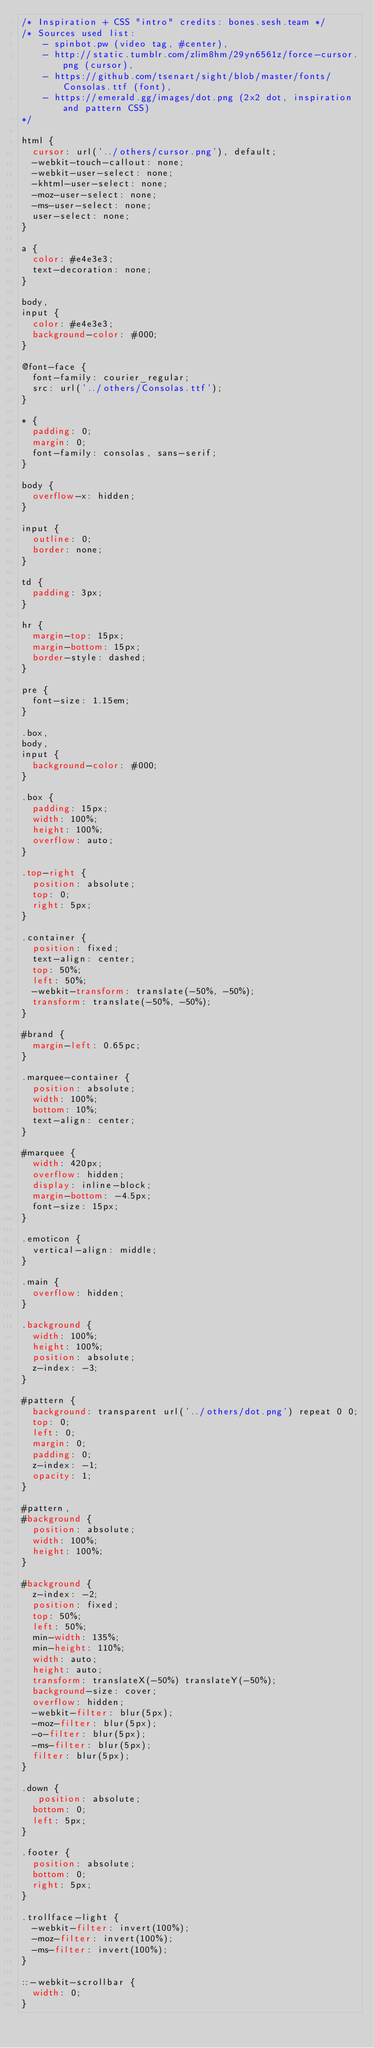Convert code to text. <code><loc_0><loc_0><loc_500><loc_500><_CSS_>/* Inspiration + CSS "intro" credits: bones.sesh.team */
/* Sources used list:
    - spinbot.pw (video tag, #center),
    - http://static.tumblr.com/zlim8hm/29yn6561z/force-cursor.png (cursor),
    - https://github.com/tsenart/sight/blob/master/fonts/Consolas.ttf (font),
    - https://emerald.gg/images/dot.png (2x2 dot, inspiration and pattern CSS)
*/

html {
  cursor: url('../others/cursor.png'), default;
  -webkit-touch-callout: none;
  -webkit-user-select: none;
  -khtml-user-select: none;
  -moz-user-select: none;
  -ms-user-select: none;
  user-select: none;
}

a {
  color: #e4e3e3;
  text-decoration: none;
}

body,
input {
  color: #e4e3e3;
  background-color: #000;
}

@font-face {
  font-family: courier_regular;
  src: url('../others/Consolas.ttf');
}

* {
  padding: 0;
  margin: 0;
  font-family: consolas, sans-serif;
}

body {
  overflow-x: hidden;
}

input {
  outline: 0;
  border: none;
}

td {
  padding: 3px;
}

hr {
  margin-top: 15px;
  margin-bottom: 15px;
  border-style: dashed;
}

pre {
  font-size: 1.15em;
}

.box,
body,
input {
  background-color: #000;
}

.box {
  padding: 15px;
  width: 100%;
  height: 100%;
  overflow: auto;
}

.top-right {
  position: absolute;
  top: 0;
  right: 5px;
}

.container {
  position: fixed;
  text-align: center;
  top: 50%;
  left: 50%;
  -webkit-transform: translate(-50%, -50%);
  transform: translate(-50%, -50%);
}

#brand {
  margin-left: 0.65pc;
}

.marquee-container {
  position: absolute;
  width: 100%;
  bottom: 10%;
  text-align: center;
}

#marquee {
  width: 420px;
  overflow: hidden;
  display: inline-block;
  margin-bottom: -4.5px;
  font-size: 15px;
}

.emoticon {
  vertical-align: middle;
}

.main {
  overflow: hidden;
}

.background {
  width: 100%;
  height: 100%;
  position: absolute;
  z-index: -3;
}

#pattern {
  background: transparent url('../others/dot.png') repeat 0 0;
  top: 0;
  left: 0;
  margin: 0;
  padding: 0;
  z-index: -1;
  opacity: 1;
}

#pattern,
#background {
  position: absolute;
  width: 100%;
  height: 100%;
}

#background {
  z-index: -2;
  position: fixed;
  top: 50%;
  left: 50%;
  min-width: 135%;
  min-height: 110%;
  width: auto;
  height: auto;
  transform: translateX(-50%) translateY(-50%);
  background-size: cover;
  overflow: hidden;
  -webkit-filter: blur(5px);
  -moz-filter: blur(5px);
  -o-filter: blur(5px);
  -ms-filter: blur(5px);
  filter: blur(5px);
}

.down {
   position: absolute;
  bottom: 0;
  left: 5px;
}

.footer {
  position: absolute;
  bottom: 0;
  right: 5px;
}

.trollface-light {
  -webkit-filter: invert(100%);
  -moz-filter: invert(100%);
  -ms-filter: invert(100%);
}

::-webkit-scrollbar {
  width: 0;
}
</code> 